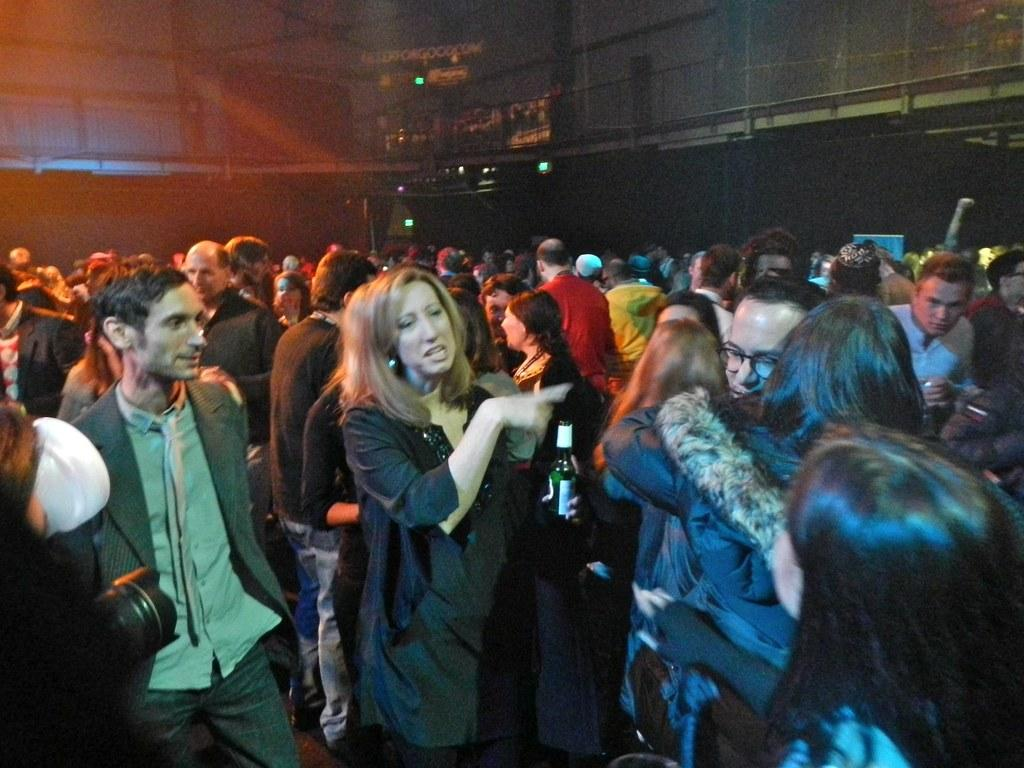What is the main subject of the image? The main subject of the image is a crowd. Where is the crowd located in the image? The crowd is on the floor. What can be seen in the background of the image? There is a building and a fence in the background of the image. What time of day is depicted in the image? The image is taken during night. What songs are being sung by the crowd in the image? There is no indication in the image that the crowd is singing songs, so it cannot be determined from the picture. 